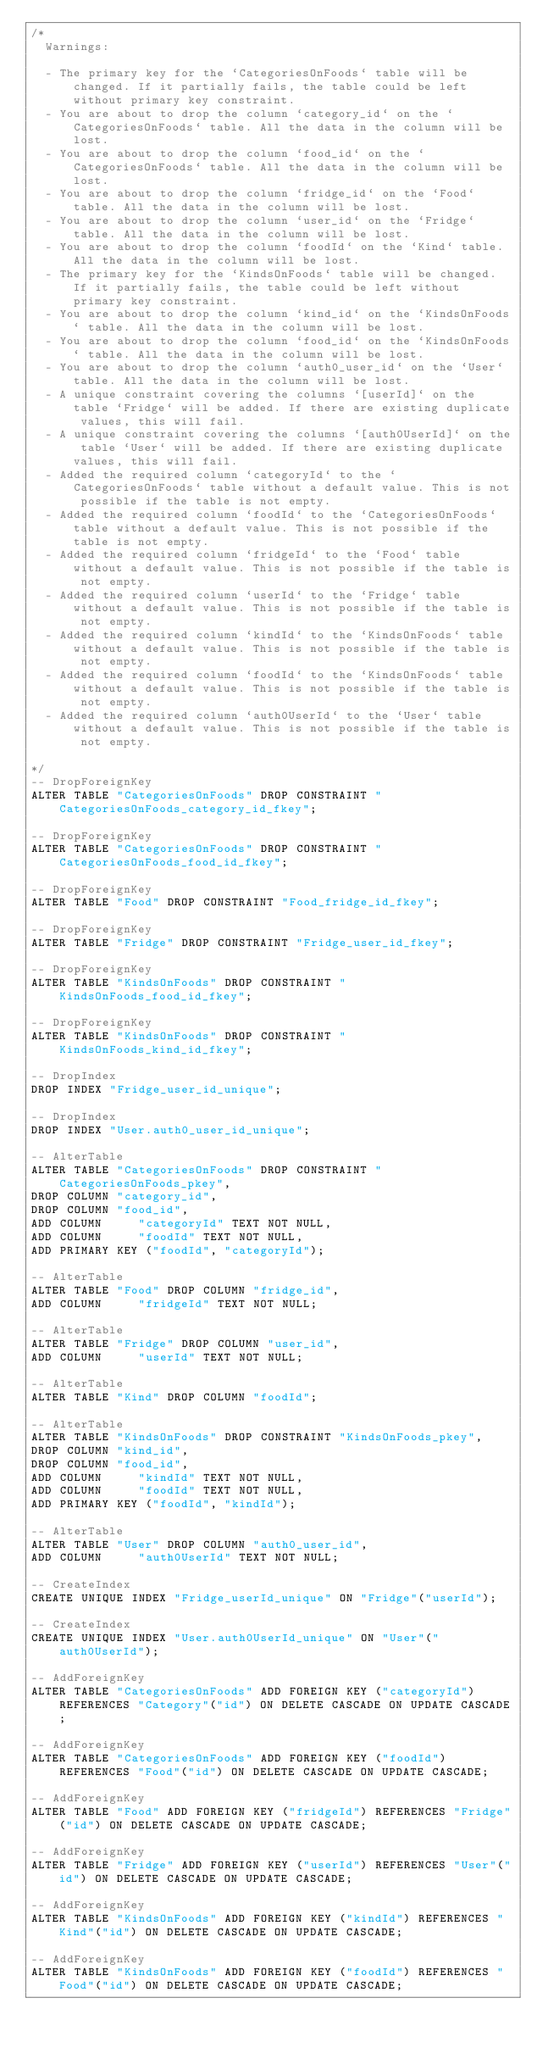Convert code to text. <code><loc_0><loc_0><loc_500><loc_500><_SQL_>/*
  Warnings:

  - The primary key for the `CategoriesOnFoods` table will be changed. If it partially fails, the table could be left without primary key constraint.
  - You are about to drop the column `category_id` on the `CategoriesOnFoods` table. All the data in the column will be lost.
  - You are about to drop the column `food_id` on the `CategoriesOnFoods` table. All the data in the column will be lost.
  - You are about to drop the column `fridge_id` on the `Food` table. All the data in the column will be lost.
  - You are about to drop the column `user_id` on the `Fridge` table. All the data in the column will be lost.
  - You are about to drop the column `foodId` on the `Kind` table. All the data in the column will be lost.
  - The primary key for the `KindsOnFoods` table will be changed. If it partially fails, the table could be left without primary key constraint.
  - You are about to drop the column `kind_id` on the `KindsOnFoods` table. All the data in the column will be lost.
  - You are about to drop the column `food_id` on the `KindsOnFoods` table. All the data in the column will be lost.
  - You are about to drop the column `auth0_user_id` on the `User` table. All the data in the column will be lost.
  - A unique constraint covering the columns `[userId]` on the table `Fridge` will be added. If there are existing duplicate values, this will fail.
  - A unique constraint covering the columns `[auth0UserId]` on the table `User` will be added. If there are existing duplicate values, this will fail.
  - Added the required column `categoryId` to the `CategoriesOnFoods` table without a default value. This is not possible if the table is not empty.
  - Added the required column `foodId` to the `CategoriesOnFoods` table without a default value. This is not possible if the table is not empty.
  - Added the required column `fridgeId` to the `Food` table without a default value. This is not possible if the table is not empty.
  - Added the required column `userId` to the `Fridge` table without a default value. This is not possible if the table is not empty.
  - Added the required column `kindId` to the `KindsOnFoods` table without a default value. This is not possible if the table is not empty.
  - Added the required column `foodId` to the `KindsOnFoods` table without a default value. This is not possible if the table is not empty.
  - Added the required column `auth0UserId` to the `User` table without a default value. This is not possible if the table is not empty.

*/
-- DropForeignKey
ALTER TABLE "CategoriesOnFoods" DROP CONSTRAINT "CategoriesOnFoods_category_id_fkey";

-- DropForeignKey
ALTER TABLE "CategoriesOnFoods" DROP CONSTRAINT "CategoriesOnFoods_food_id_fkey";

-- DropForeignKey
ALTER TABLE "Food" DROP CONSTRAINT "Food_fridge_id_fkey";

-- DropForeignKey
ALTER TABLE "Fridge" DROP CONSTRAINT "Fridge_user_id_fkey";

-- DropForeignKey
ALTER TABLE "KindsOnFoods" DROP CONSTRAINT "KindsOnFoods_food_id_fkey";

-- DropForeignKey
ALTER TABLE "KindsOnFoods" DROP CONSTRAINT "KindsOnFoods_kind_id_fkey";

-- DropIndex
DROP INDEX "Fridge_user_id_unique";

-- DropIndex
DROP INDEX "User.auth0_user_id_unique";

-- AlterTable
ALTER TABLE "CategoriesOnFoods" DROP CONSTRAINT "CategoriesOnFoods_pkey",
DROP COLUMN "category_id",
DROP COLUMN "food_id",
ADD COLUMN     "categoryId" TEXT NOT NULL,
ADD COLUMN     "foodId" TEXT NOT NULL,
ADD PRIMARY KEY ("foodId", "categoryId");

-- AlterTable
ALTER TABLE "Food" DROP COLUMN "fridge_id",
ADD COLUMN     "fridgeId" TEXT NOT NULL;

-- AlterTable
ALTER TABLE "Fridge" DROP COLUMN "user_id",
ADD COLUMN     "userId" TEXT NOT NULL;

-- AlterTable
ALTER TABLE "Kind" DROP COLUMN "foodId";

-- AlterTable
ALTER TABLE "KindsOnFoods" DROP CONSTRAINT "KindsOnFoods_pkey",
DROP COLUMN "kind_id",
DROP COLUMN "food_id",
ADD COLUMN     "kindId" TEXT NOT NULL,
ADD COLUMN     "foodId" TEXT NOT NULL,
ADD PRIMARY KEY ("foodId", "kindId");

-- AlterTable
ALTER TABLE "User" DROP COLUMN "auth0_user_id",
ADD COLUMN     "auth0UserId" TEXT NOT NULL;

-- CreateIndex
CREATE UNIQUE INDEX "Fridge_userId_unique" ON "Fridge"("userId");

-- CreateIndex
CREATE UNIQUE INDEX "User.auth0UserId_unique" ON "User"("auth0UserId");

-- AddForeignKey
ALTER TABLE "CategoriesOnFoods" ADD FOREIGN KEY ("categoryId") REFERENCES "Category"("id") ON DELETE CASCADE ON UPDATE CASCADE;

-- AddForeignKey
ALTER TABLE "CategoriesOnFoods" ADD FOREIGN KEY ("foodId") REFERENCES "Food"("id") ON DELETE CASCADE ON UPDATE CASCADE;

-- AddForeignKey
ALTER TABLE "Food" ADD FOREIGN KEY ("fridgeId") REFERENCES "Fridge"("id") ON DELETE CASCADE ON UPDATE CASCADE;

-- AddForeignKey
ALTER TABLE "Fridge" ADD FOREIGN KEY ("userId") REFERENCES "User"("id") ON DELETE CASCADE ON UPDATE CASCADE;

-- AddForeignKey
ALTER TABLE "KindsOnFoods" ADD FOREIGN KEY ("kindId") REFERENCES "Kind"("id") ON DELETE CASCADE ON UPDATE CASCADE;

-- AddForeignKey
ALTER TABLE "KindsOnFoods" ADD FOREIGN KEY ("foodId") REFERENCES "Food"("id") ON DELETE CASCADE ON UPDATE CASCADE;
</code> 